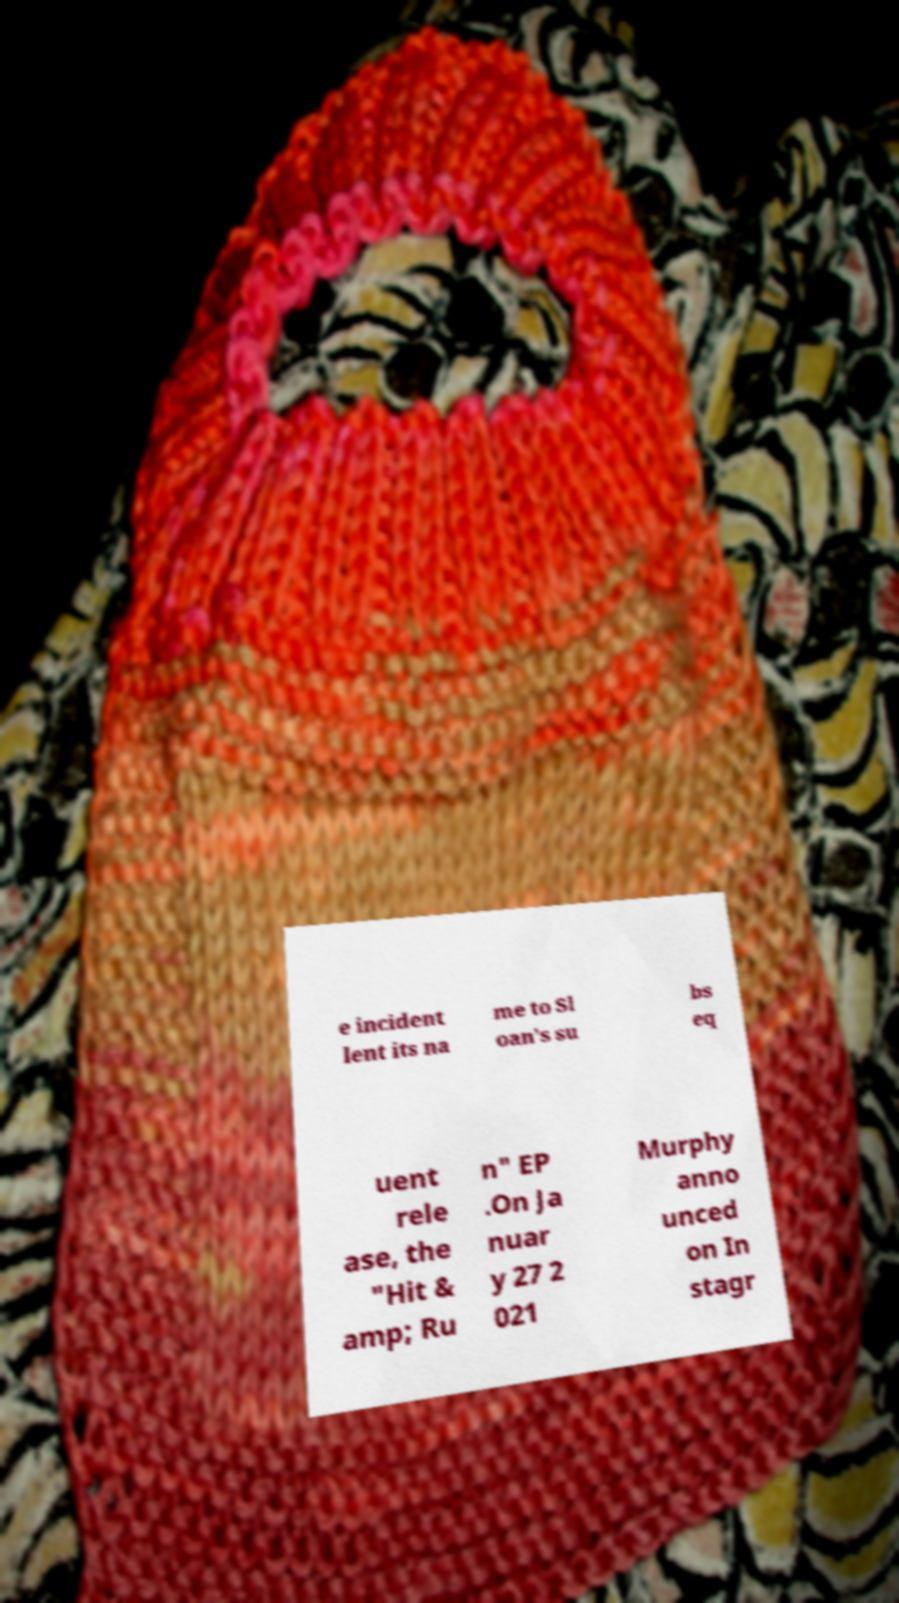Please identify and transcribe the text found in this image. e incident lent its na me to Sl oan's su bs eq uent rele ase, the "Hit & amp; Ru n" EP .On Ja nuar y 27 2 021 Murphy anno unced on In stagr 